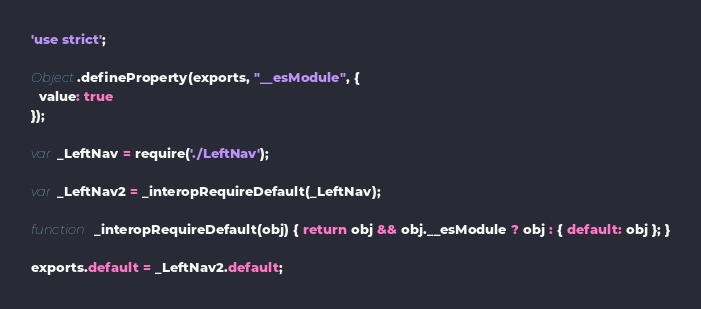Convert code to text. <code><loc_0><loc_0><loc_500><loc_500><_JavaScript_>'use strict';

Object.defineProperty(exports, "__esModule", {
  value: true
});

var _LeftNav = require('./LeftNav');

var _LeftNav2 = _interopRequireDefault(_LeftNav);

function _interopRequireDefault(obj) { return obj && obj.__esModule ? obj : { default: obj }; }

exports.default = _LeftNav2.default;</code> 